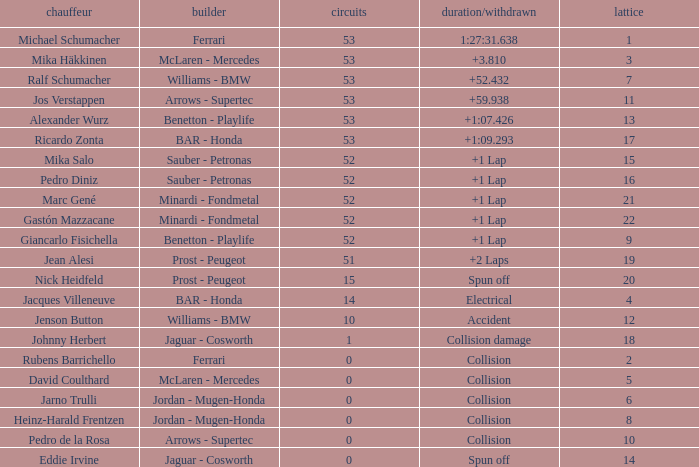How many laps did Ricardo Zonta have? 53.0. 